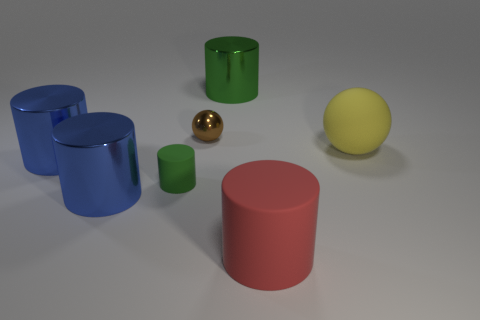Subtract all large matte cylinders. How many cylinders are left? 4 Subtract all red cylinders. How many cylinders are left? 4 Subtract all cyan cylinders. Subtract all cyan cubes. How many cylinders are left? 5 Add 2 large metallic objects. How many objects exist? 9 Subtract all spheres. How many objects are left? 5 Subtract all green things. Subtract all large matte objects. How many objects are left? 3 Add 3 large blue objects. How many large blue objects are left? 5 Add 3 big things. How many big things exist? 8 Subtract 0 purple spheres. How many objects are left? 7 